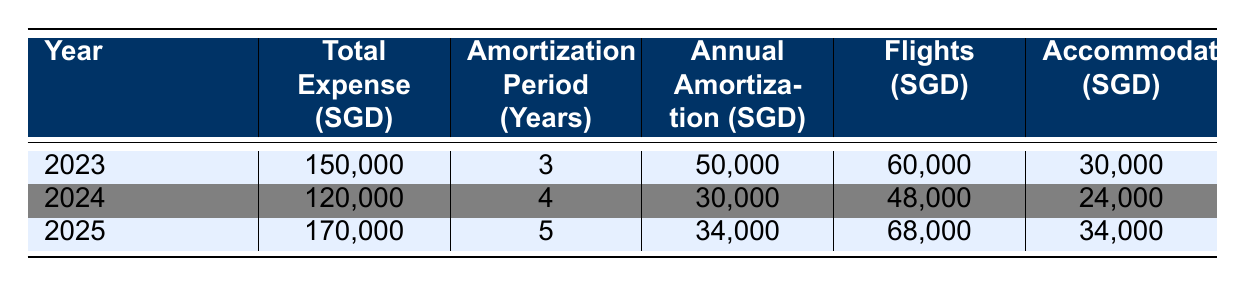What is the total expense for the Singapore National Athletics Team in 2023? The total expense for the Singapore National Athletics Team in 2023 is listed directly in the table under the "Total Expense (SGD)" column for the year 2023. It shows a value of 150,000 SGD.
Answer: 150,000 SGD What is the annual amortization amount for the year 2024? The annual amortization for 2024 is found in the "Annual Amortization (SGD)" column for that year, which states it is 30,000 SGD.
Answer: 30,000 SGD Which year has the highest total expense? By comparing the "Total Expense (SGD)" for each year, we see that 2025 has the highest total expense at 170,000 SGD, followed by 2023 at 150,000 SGD and 2024 at 120,000 SGD.
Answer: 2025 What is the average annual amortization amount across the years? To find the average, sum the annual amortization amounts (50,000 + 30,000 + 34,000 = 114,000) and divide by the number of years (3). The average is 114,000 / 3 = 38,000 SGD.
Answer: 38,000 SGD Are all years showing an increase in annual amortization? Checking the annual amortization values for the years, we see they are 50,000 SGD for 2023, 30,000 SGD for 2024, and 34,000 SGD for 2025. The amounts do not consistently increase, as 2024 has a lower amount than 2023.
Answer: No What is the total cost for flights over the three years? The total cost for flights is calculated by summing the amounts for each year: 60,000 SGD for 2023, 48,000 SGD for 2024, and 68,000 SGD for 2025. This totals to 60,000 + 48,000 + 68,000 = 176,000 SGD.
Answer: 176,000 SGD In which year did the team spend the most on accommodation? By looking at the "Accommodation (SGD)" column, we can see the values are 30,000 for 2023, 24,000 for 2024, and 34,000 for 2025. The highest spending was 34,000 SGD in 2025.
Answer: 2025 What is the difference in total expenses between 2023 and 2024? To find the difference, we subtract the total expense for 2024 (120,000 SGD) from that of 2023 (150,000 SGD): 150,000 - 120,000 = 30,000 SGD.
Answer: 30,000 SGD Is the total expense for 2023 greater than the combined total of 2024 and 2025? First, calculate the combined total for 2024 and 2025: 120,000 + 170,000 = 290,000 SGD. Since 150,000 SGD for 2023 is less than 290,000 SGD, the statement is false.
Answer: No 